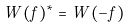Convert formula to latex. <formula><loc_0><loc_0><loc_500><loc_500>W ( f ) ^ { * } = W ( - f )</formula> 